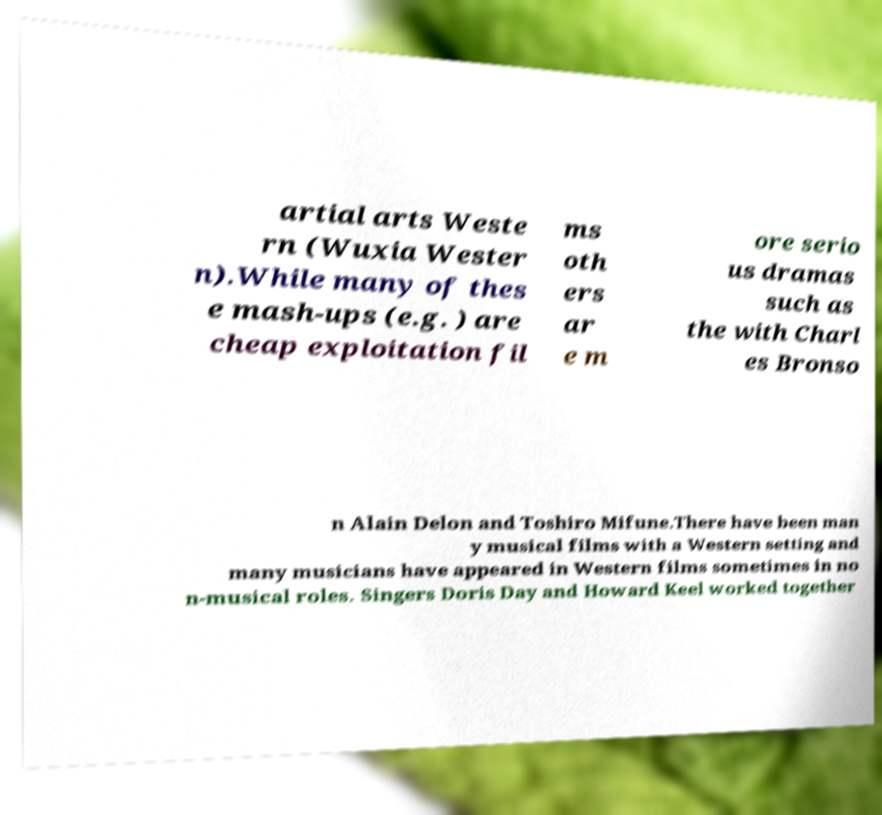There's text embedded in this image that I need extracted. Can you transcribe it verbatim? artial arts Weste rn (Wuxia Wester n).While many of thes e mash-ups (e.g. ) are cheap exploitation fil ms oth ers ar e m ore serio us dramas such as the with Charl es Bronso n Alain Delon and Toshiro Mifune.There have been man y musical films with a Western setting and many musicians have appeared in Western films sometimes in no n-musical roles. Singers Doris Day and Howard Keel worked together 